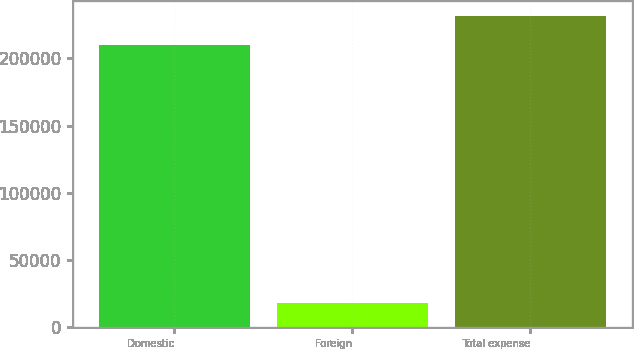Convert chart. <chart><loc_0><loc_0><loc_500><loc_500><bar_chart><fcel>Domestic<fcel>Foreign<fcel>Total expense<nl><fcel>210295<fcel>17628<fcel>231324<nl></chart> 